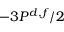<formula> <loc_0><loc_0><loc_500><loc_500>- 3 P ^ { d , f } / 2</formula> 